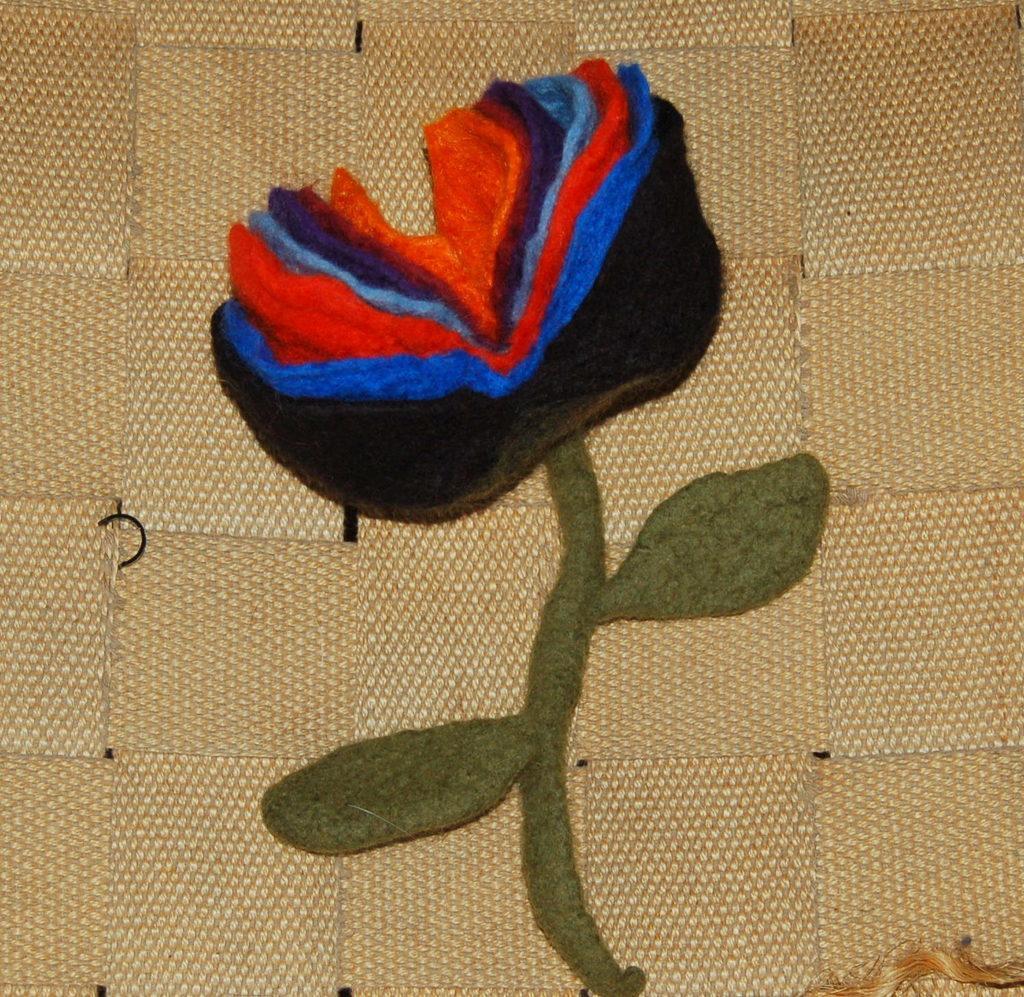Could you give a brief overview of what you see in this image? In this picture I can see there is flower stitched on a fabric and the fabric is of brown color. 